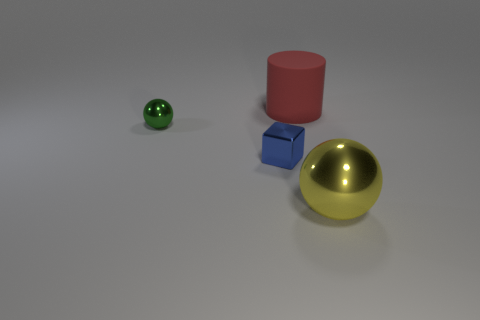What is the material of the large red cylinder?
Your answer should be very brief. Rubber. There is a metal sphere behind the blue shiny block; does it have the same size as the blue object?
Your response must be concise. Yes. What number of objects are either tiny green metallic objects or large yellow objects?
Ensure brevity in your answer.  2. How big is the object that is behind the tiny blue shiny cube and to the right of the green shiny ball?
Your answer should be very brief. Large. How many large metallic spheres are there?
Your answer should be very brief. 1. How many cylinders are either red matte objects or large things?
Your response must be concise. 1. There is a metal sphere that is in front of the sphere behind the metal cube; how many green metal things are left of it?
Your answer should be compact. 1. There is a object that is the same size as the blue cube; what is its color?
Your response must be concise. Green. How many other things are there of the same color as the large matte cylinder?
Ensure brevity in your answer.  0. Is the number of red rubber things that are behind the big matte object greater than the number of red things?
Your answer should be compact. No. 